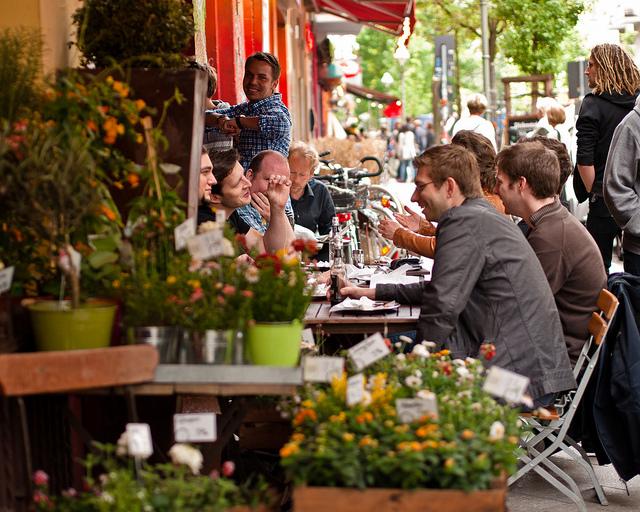How many people are in the picture?
Be succinct. 20. What is under the tables?
Short answer required. Legs. Is this a banana farm?
Concise answer only. No. What are the people doing?
Short answer required. Eating. Are people sitting around a barrel?
Short answer required. No. Are there any flowers in the photo?
Quick response, please. Yes. What is the man sitting on?
Keep it brief. Chair. Are all the plants in full bloom?
Write a very short answer. Yes. Why are people seated in this outdoor area?
Keep it brief. Eating. 